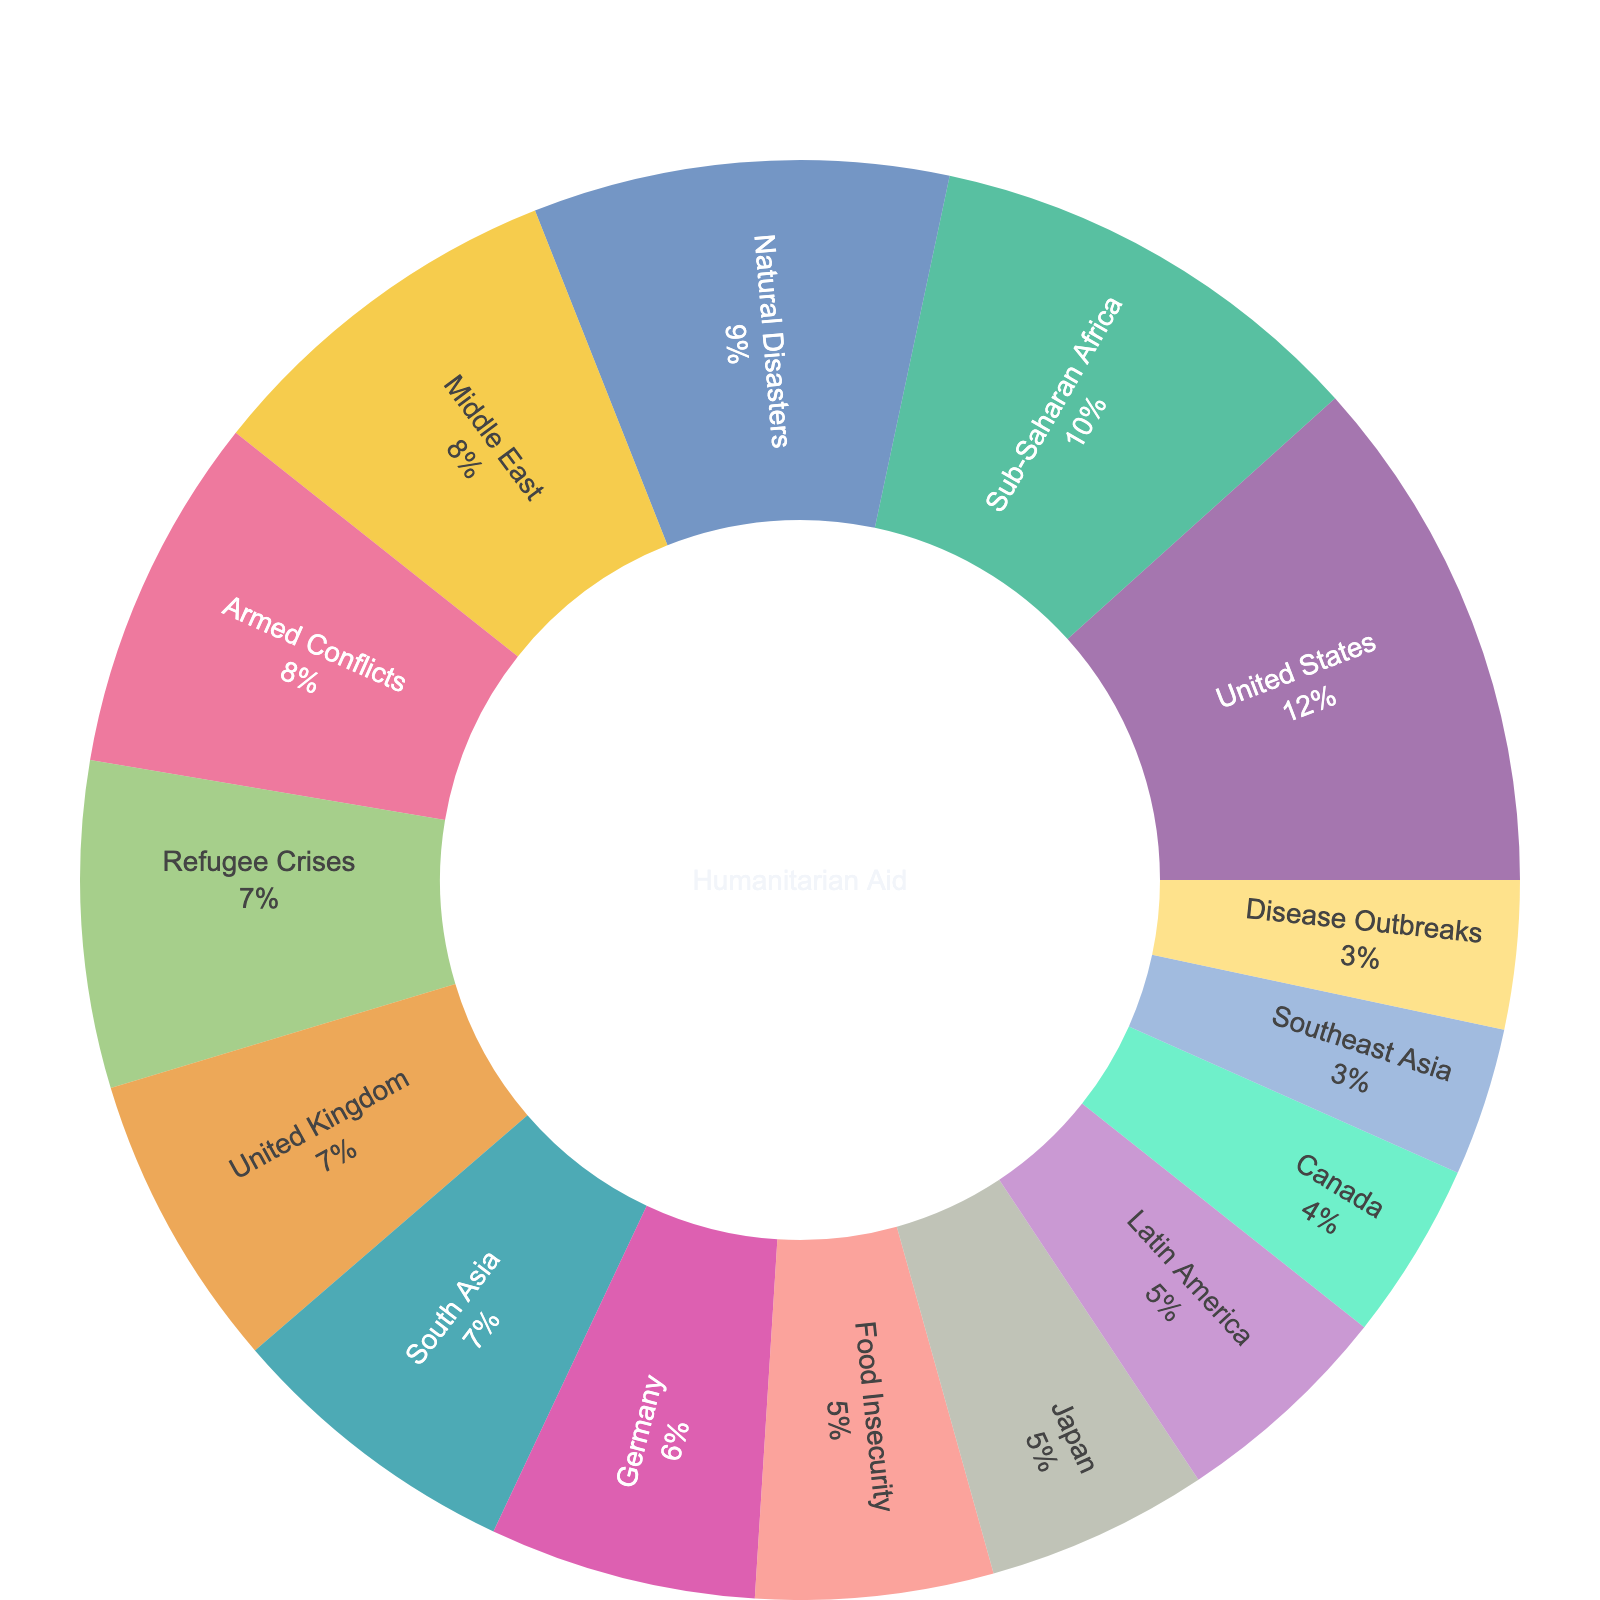What is the title of the figure? The title can be found at the top of the figure, typically displayed prominently. In this case, it is "Allocation of Humanitarian Aid Funding".
Answer: Allocation of Humanitarian Aid Funding Which donor country contributes the highest amount to humanitarian aid? You would look at the section of the sunburst plot designated for donor countries and identify the one with the largest value. This is the United States with 35.
Answer: United States What percentage of humanitarian aid funding is allocated to Sub-Saharan Africa? Observe the “Recipient Regions” section of the sunburst and look for Sub-Saharan Africa. The percentage is displayed next to the label within the plot.
Answer: 30% How much more aid does the United States contribute compared to Canada? Find the values for both the United States and Canada in the donor countries section, then subtract the value for Canada from the value for the United States (35-12).
Answer: 23 Combine the aid allocations of the Middle East and South Asia. What is the result? Locate the values for the Middle East and South Asia in the “Recipient Regions” section and sum them up (25 + 20).
Answer: 45 Compare the aid allocation for natural disasters and food insecurity. Which type receives more funding? Look at the "Crisis Types" section and compare the values for natural disasters (28) and food insecurity (16). Natural disasters receive more funding.
Answer: Natural Disasters What is the total funding allocation from European countries (United Kingdom and Germany)? Find the values for both the United Kingdom and Germany in the “Donor Countries” section and sum them up (20 + 18).
Answer: 38 Which recipient region gets the lowest amount of aid funding? Look at the "Recipient Regions" section and identify the segment with the smallest value, which is Southeast Asia with 10.
Answer: Southeast Asia What percentage of funding goes towards refugee crises? Locate the "Crisis Types" section and find the percentage associated with refugee crises.
Answer: 22% Identify the donor countries that contribute more than 15 units of aid funding. Look at the "Donor Countries" section and list those countries with values greater than 15: United States, United Kingdom, Germany, and Japan.
Answer: United States, United Kingdom, Germany, Japan 